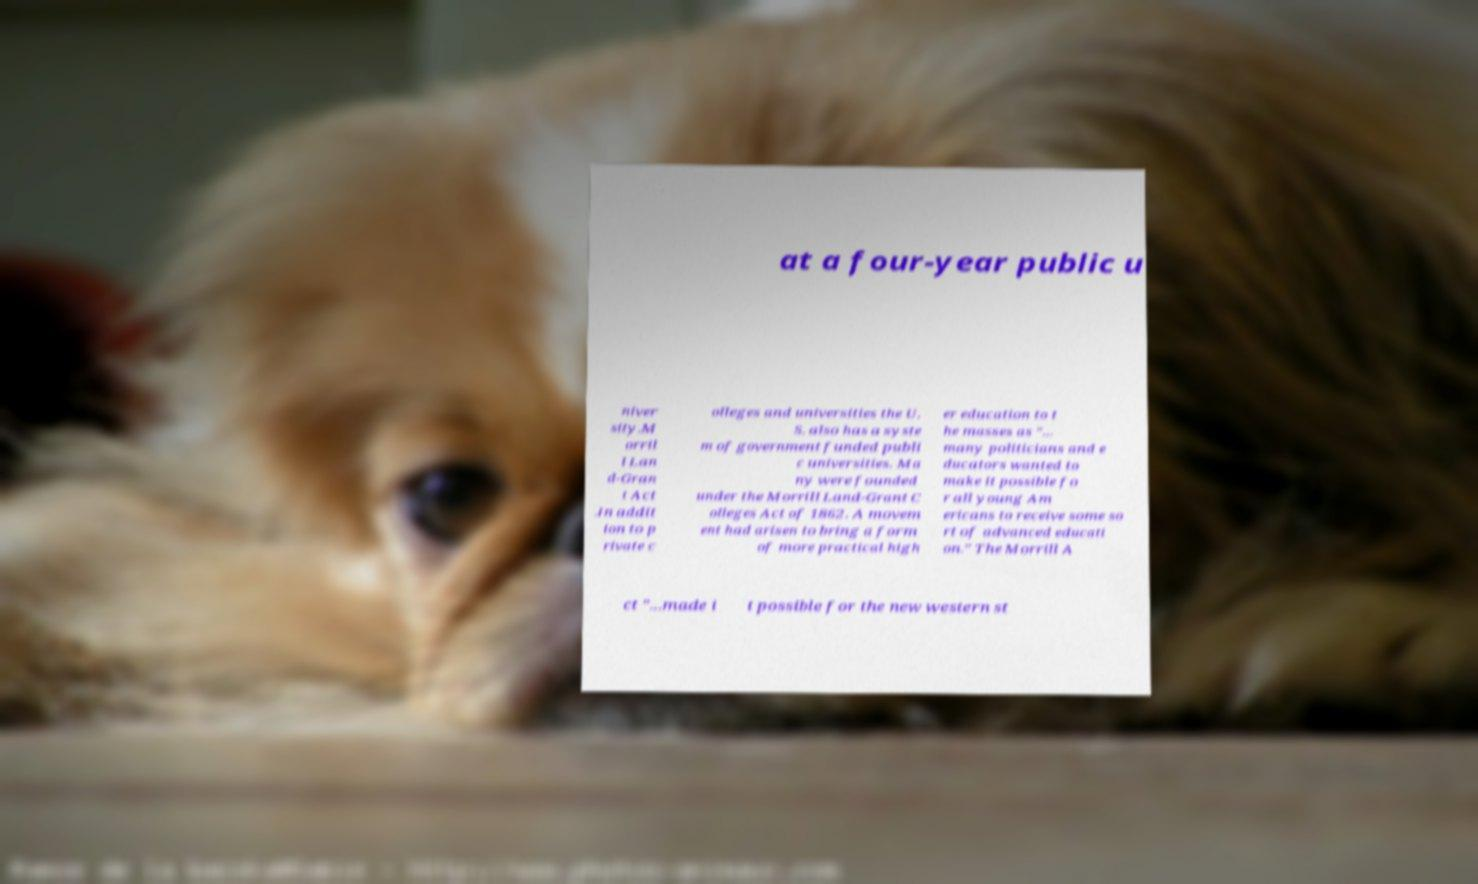I need the written content from this picture converted into text. Can you do that? at a four-year public u niver sity.M orril l Lan d-Gran t Act .In addit ion to p rivate c olleges and universities the U. S. also has a syste m of government funded publi c universities. Ma ny were founded under the Morrill Land-Grant C olleges Act of 1862. A movem ent had arisen to bring a form of more practical high er education to t he masses as "... many politicians and e ducators wanted to make it possible fo r all young Am ericans to receive some so rt of advanced educati on." The Morrill A ct "...made i t possible for the new western st 